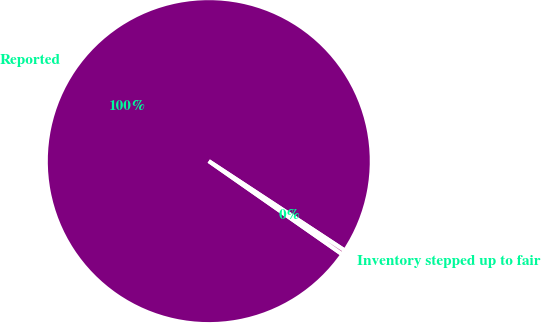Convert chart to OTSL. <chart><loc_0><loc_0><loc_500><loc_500><pie_chart><fcel>Reported<fcel>Inventory stepped up to fair<nl><fcel>99.55%<fcel>0.45%<nl></chart> 